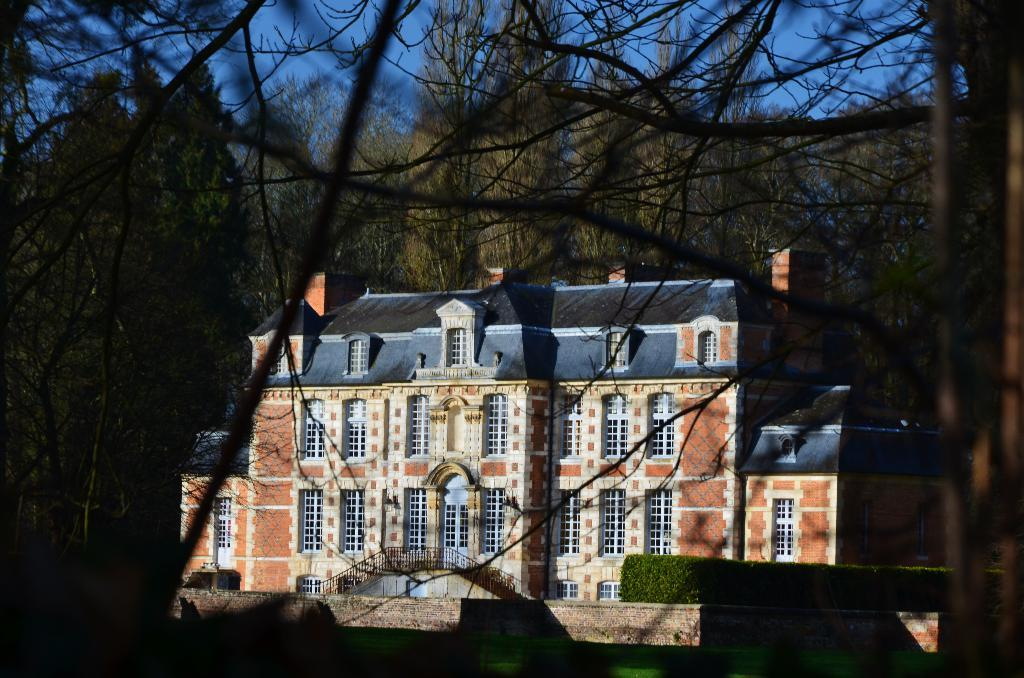What is the main structure in the center of the image? There is a building in the center of the image. What can be found in the center of the image besides the building? There are stairs and a hedge in the center of the image. What type of vegetation is visible in the background of the image? There are trees in the background of the image. What type of sack can be seen hanging from the hedge in the image? There is no sack present in the image, and therefore no such object can be observed hanging from the hedge. 